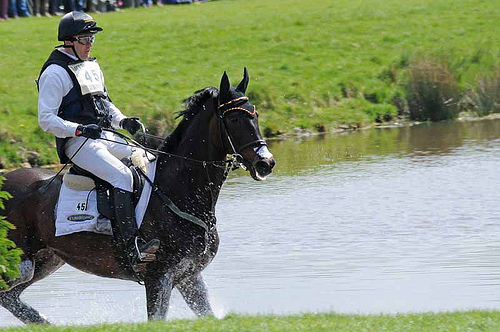On which side of the picture is the man? The man is on the left side of the picture. 